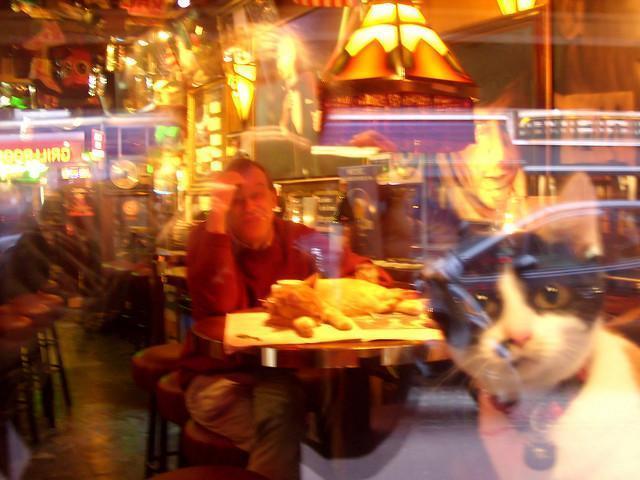How many chairs are in the picture?
Give a very brief answer. 2. How many cats are in the picture?
Give a very brief answer. 2. How many dining tables can be seen?
Give a very brief answer. 1. How many elephants are in this scene?
Give a very brief answer. 0. 